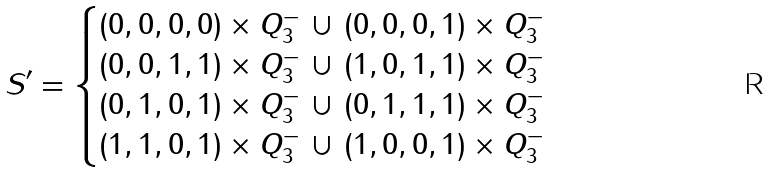<formula> <loc_0><loc_0><loc_500><loc_500>S ^ { \prime } = \begin{cases} ( 0 , 0 , 0 , 0 ) \times Q _ { 3 } ^ { - } \, \cup \, ( 0 , 0 , 0 , 1 ) \times Q _ { 3 } ^ { - } \\ ( 0 , 0 , 1 , 1 ) \times Q _ { 3 } ^ { - } \, \cup \, ( 1 , 0 , 1 , 1 ) \times Q _ { 3 } ^ { - } \\ ( 0 , 1 , 0 , 1 ) \times Q _ { 3 } ^ { - } \, \cup \, ( 0 , 1 , 1 , 1 ) \times Q _ { 3 } ^ { - } \\ ( 1 , 1 , 0 , 1 ) \times Q _ { 3 } ^ { - } \, \cup \, ( 1 , 0 , 0 , 1 ) \times Q _ { 3 } ^ { - } \end{cases}</formula> 